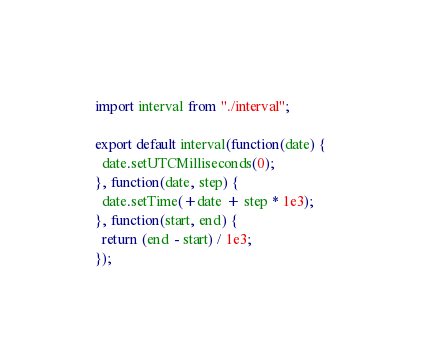Convert code to text. <code><loc_0><loc_0><loc_500><loc_500><_JavaScript_>import interval from "./interval";

export default interval(function(date) {
  date.setUTCMilliseconds(0);
}, function(date, step) {
  date.setTime(+date + step * 1e3);
}, function(start, end) {
  return (end - start) / 1e3;
});
</code> 